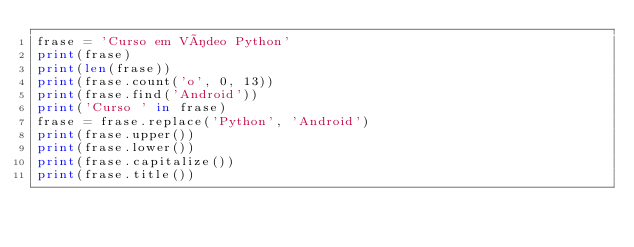<code> <loc_0><loc_0><loc_500><loc_500><_Python_>frase = 'Curso em Vídeo Python'
print(frase)
print(len(frase))
print(frase.count('o', 0, 13))
print(frase.find('Android'))
print('Curso ' in frase)
frase = frase.replace('Python', 'Android')
print(frase.upper())
print(frase.lower())
print(frase.capitalize())
print(frase.title())
</code> 